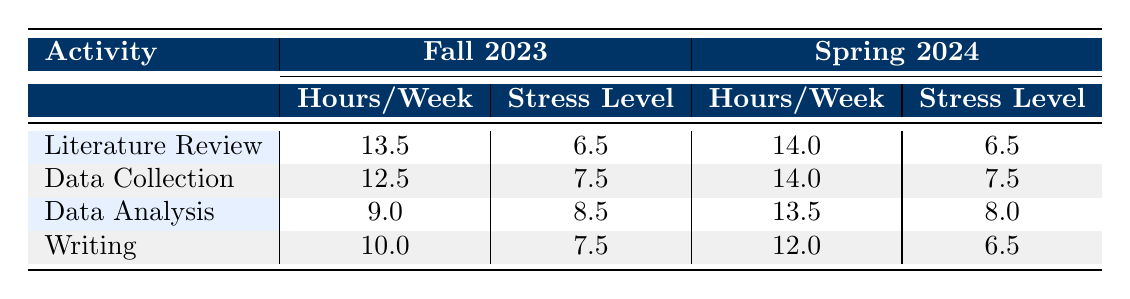What is the average number of hours per week devoted to "Literature Review" in Fall 2023? For Fall 2023, there are two students’ hours for Literature Review: NSP001(15 hours) and NSP002(12 hours). Adding these gives 15 + 12 = 27 hours. Dividing by the number of students (2), we get 27/2 = 13.5.
Answer: 13.5 Which activity had the highest stress level in Fall 2023? Reviewing the stress levels for each activity in Fall 2023: Literature Review (7), Data Collection (8), Data Analysis (9), Writing (8). The highest stress level is for Data Analysis, which is 9.
Answer: Data Analysis Is the average stress level for "Writing" lower in Spring 2024 compared to Fall 2023? The average stress level for Writing in Fall 2023 is 8 and in Spring 2024 it is 6. Comparing these two values, 6 is lower than 8, indicating that it is lower in Spring 2024.
Answer: Yes How many total hours per week do students spend on "Data Collection" across both semesters? For Fall 2023, the hours for Data Collection are 10 (NSP001) and 15 (NSP002), totaling 25 hours. In Spring 2024, it is 20 hours (NSP003) and 8 hours (NSP004), totaling another 28 hours. Summing these gives 25 + 28 = 53 hours.
Answer: 53 What is the difference in average hours spent on "Data Analysis" between Fall 2023 and Spring 2024? The average hours spent on Data Analysis in Fall 2023 is 8 hours (from NSP001). In Spring 2024, it is 12 hours (from NSP003) and 15 hours (from NSP004). Averaging these gives (12 + 15)/2 = 13.5 hours. The difference is 13.5 - 9 = 4.5 hours.
Answer: 4.5 In which semester do students spend more time on "Writing"? In Fall 2023, the average for Writing is 12 hours, and in Spring 2024, it is 10 hours (from NSP003 and NSP004). Since 12 is greater than 10, students spend more time on Writing in Fall 2023.
Answer: Fall 2023 Are students more stressed on average during "Data Analysis" compared to "Literature Review" in Spring 2024? The average stress level for Data Analysis in Spring 2024 is 8 while for Literature Review, it is 6. Since 8 is greater than 6, students are more stressed during Data Analysis.
Answer: Yes What is the combined total of hours dedicated to "Data Analysis" in both semesters? In Fall 2023, Data Analysis hours are 8 (NSP001), totaling 8 hours. In Spring 2024, it is 12 hours (NSP003) and 15 hours (NSP004), totaling 27 hours. The combined total is 8 + 27 = 35 hours.
Answer: 35 